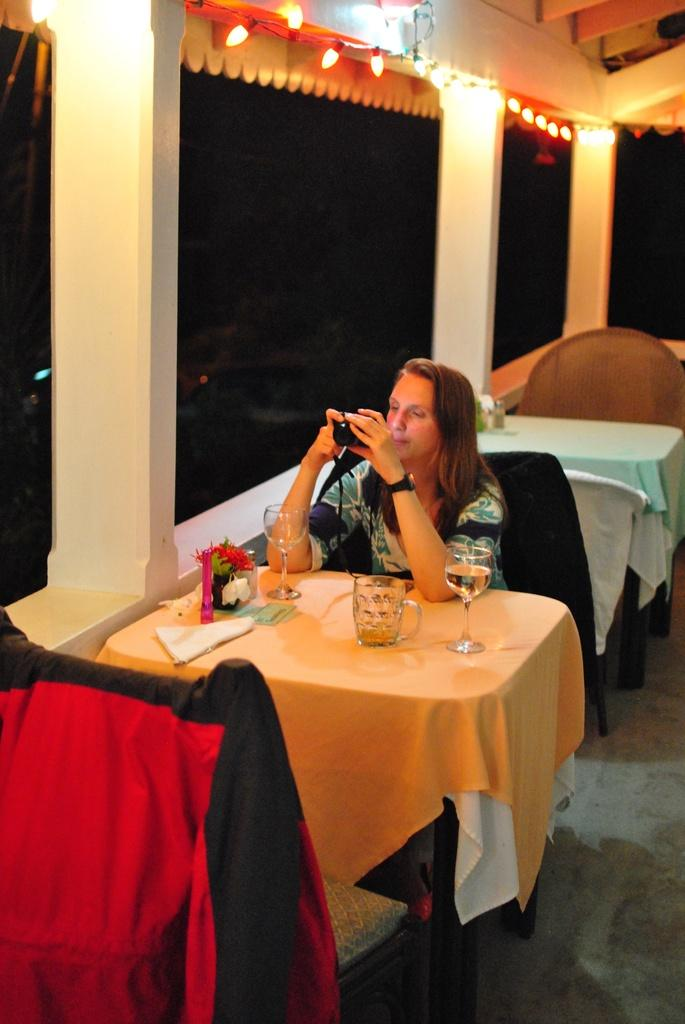What is the person in the image doing? The person is sitting on a chair. What is located next to the person? There is a table in the image. What can be seen on the table? There is a glass, a flower vase, and tissues on the table. What insurance policy is the person discussing with the group in the image? There is no group present in the image, and no discussion about insurance is taking place. 